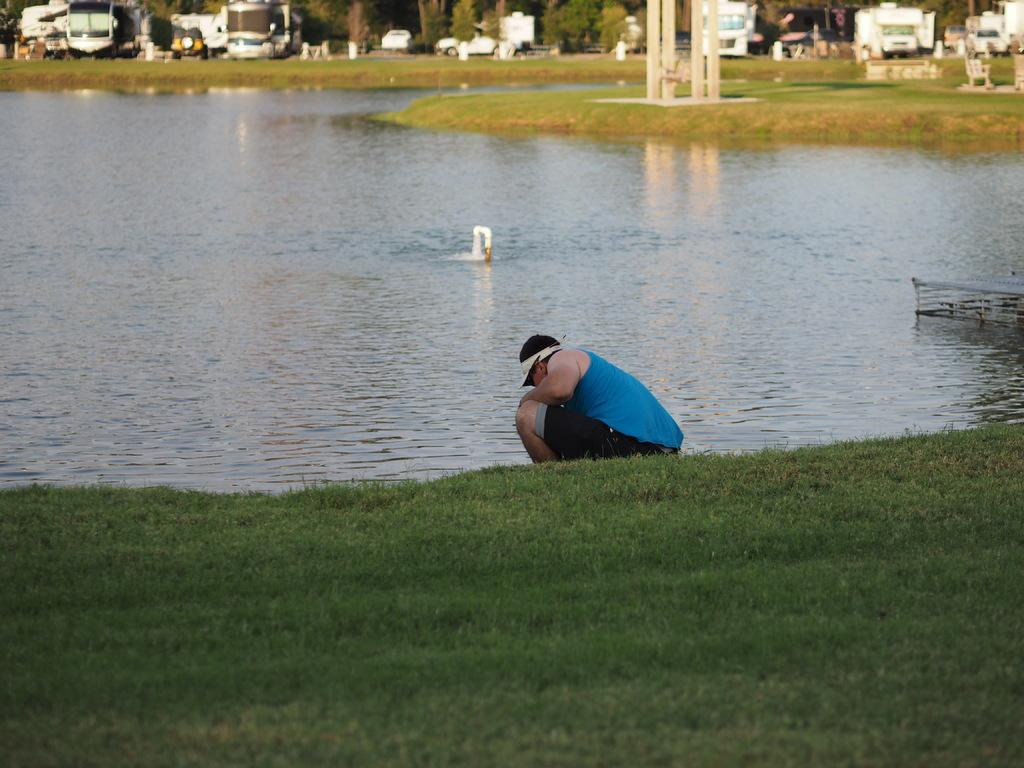What is present in the image? There is a person and grass in the image. What else can be seen in the image? There is water visible in the image. How does the nation affect the image? The image does not depict a nation or any political entity; it only shows a person, grass, and water. 